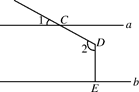What can we learn about the properties of perpendicular and parallel lines from this diagram? This diagram is a great illustration of several fundamental geometrical concepts. First, when lines are parallel such as lines a and b, we observe that all corresponding angles are equal when a transversal line (like CD here) intersects them. Moreover, because DE is perpendicular to b (and hence to a as they are parallel), angles at point D are right angles, at exactly 90 degrees. This ensures predictability in calculations and foundational rules in geometric constructions. 